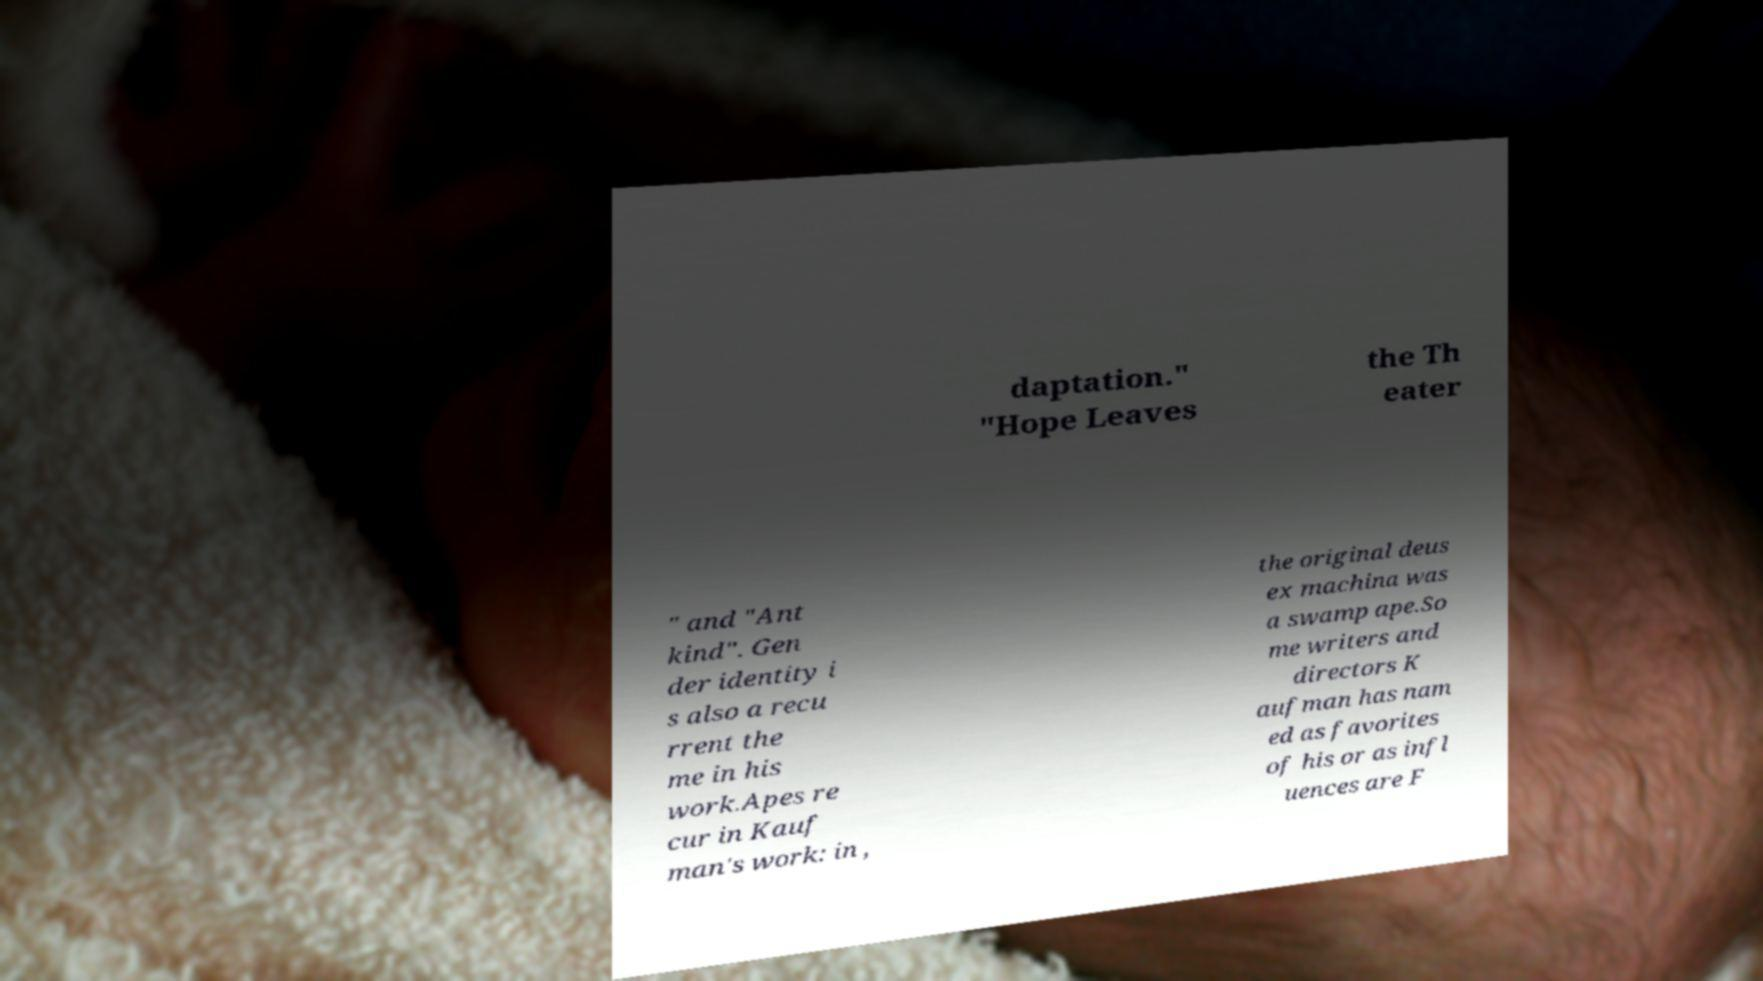Please identify and transcribe the text found in this image. daptation." "Hope Leaves the Th eater " and "Ant kind". Gen der identity i s also a recu rrent the me in his work.Apes re cur in Kauf man's work: in , the original deus ex machina was a swamp ape.So me writers and directors K aufman has nam ed as favorites of his or as infl uences are F 